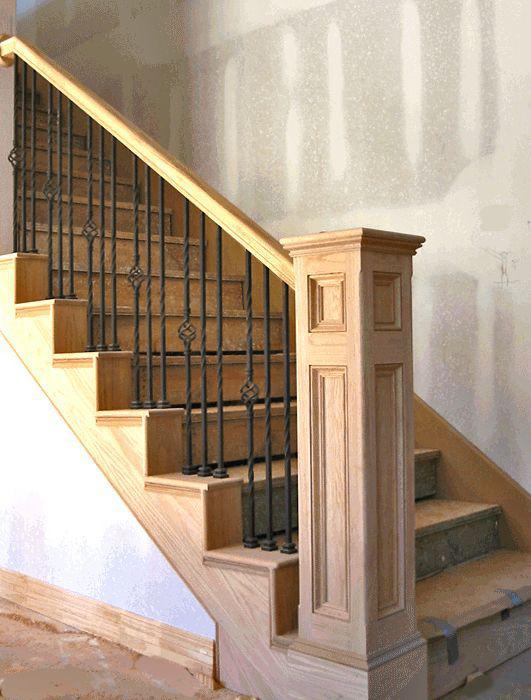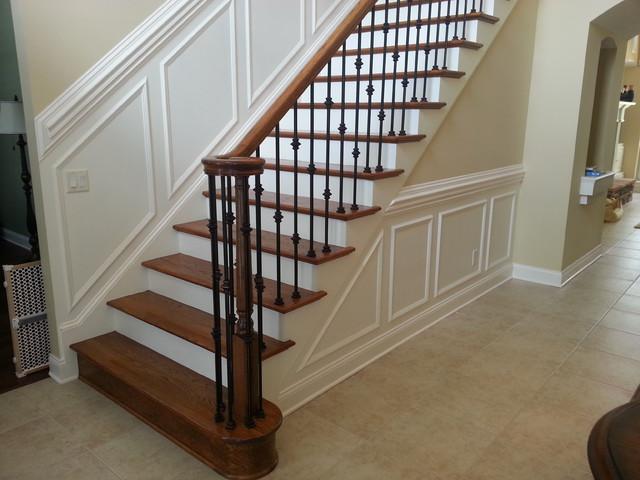The first image is the image on the left, the second image is the image on the right. Considering the images on both sides, is "An image shows a staircase that ascends rightward next to an arch doorway, and the staircase has wooden steps with white base boards." valid? Answer yes or no. Yes. The first image is the image on the left, the second image is the image on the right. Given the left and right images, does the statement "One set of vertical railings is plain with no design." hold true? Answer yes or no. No. 